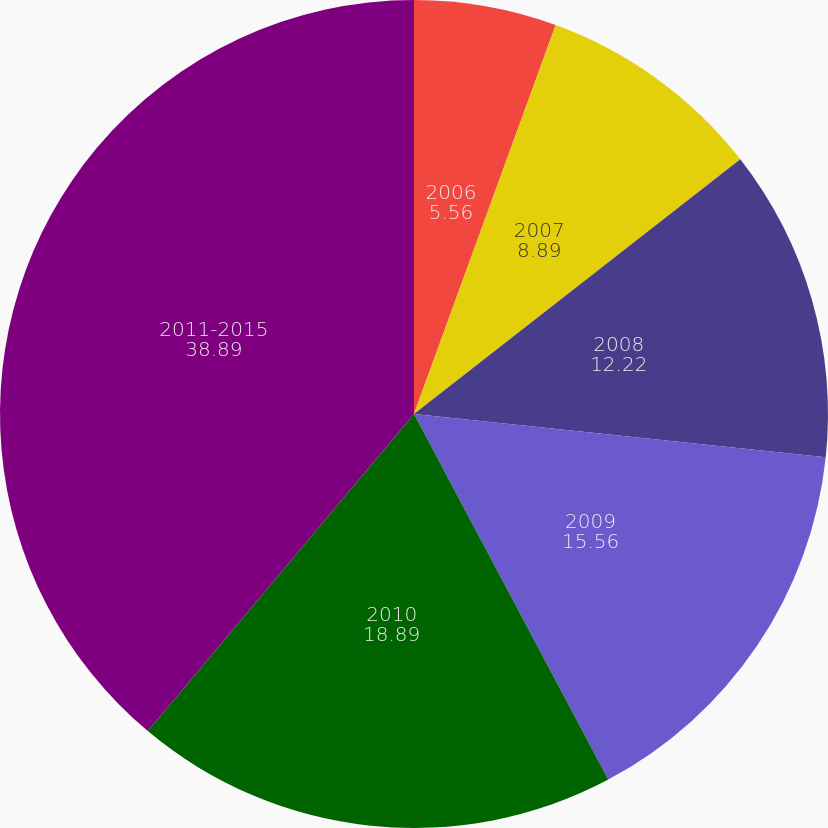Convert chart to OTSL. <chart><loc_0><loc_0><loc_500><loc_500><pie_chart><fcel>2006<fcel>2007<fcel>2008<fcel>2009<fcel>2010<fcel>2011-2015<nl><fcel>5.56%<fcel>8.89%<fcel>12.22%<fcel>15.56%<fcel>18.89%<fcel>38.89%<nl></chart> 